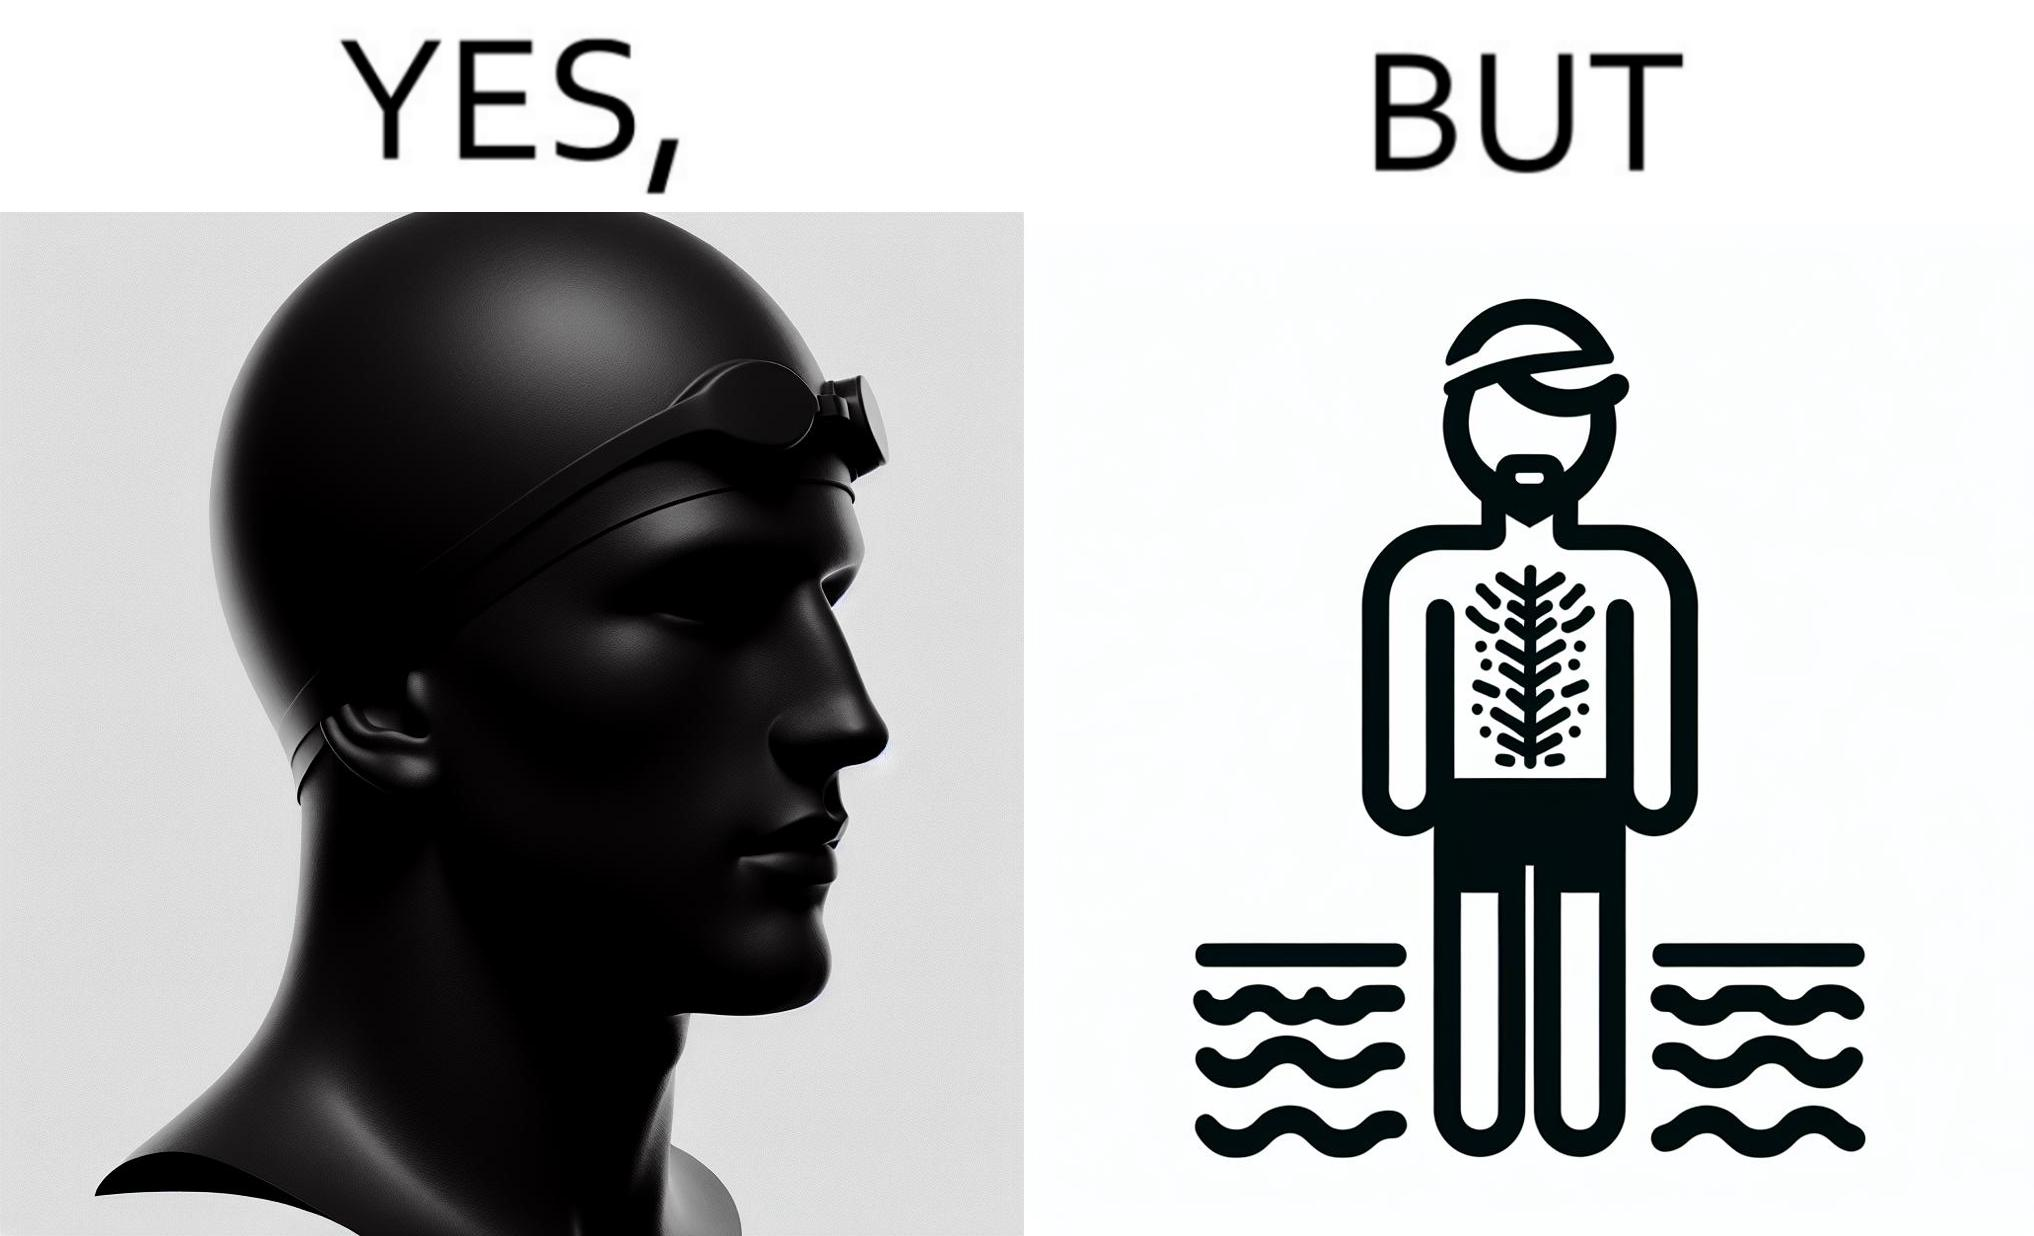What makes this image funny or satirical? The man is wearing a swimming cap to protect his head's hair but on the other side he is not concerned over the hair all over his body and is nowhere covering them 